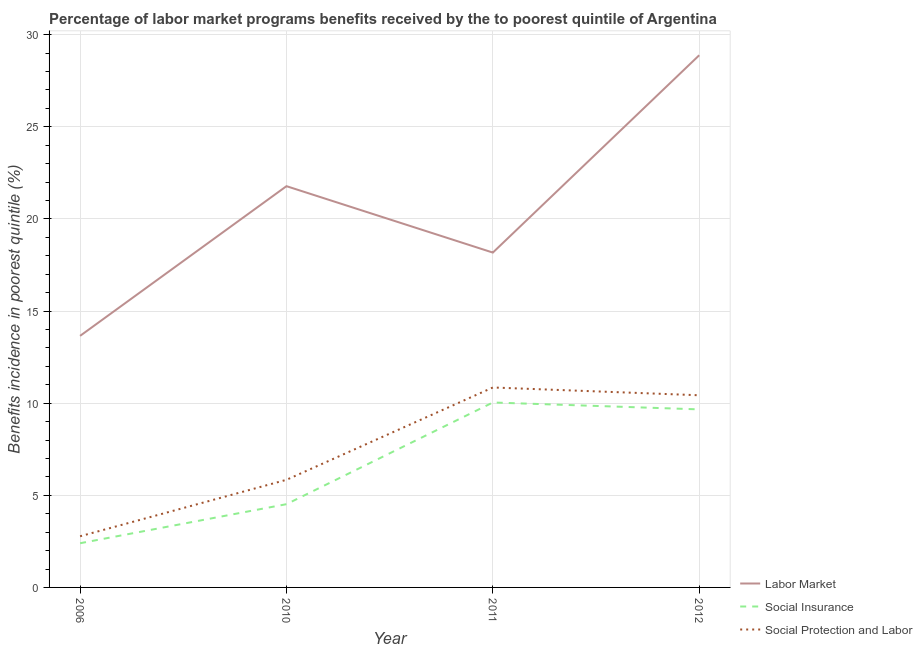Does the line corresponding to percentage of benefits received due to social protection programs intersect with the line corresponding to percentage of benefits received due to labor market programs?
Ensure brevity in your answer.  No. Is the number of lines equal to the number of legend labels?
Offer a terse response. Yes. What is the percentage of benefits received due to labor market programs in 2010?
Your response must be concise. 21.78. Across all years, what is the maximum percentage of benefits received due to social insurance programs?
Keep it short and to the point. 10.04. Across all years, what is the minimum percentage of benefits received due to social insurance programs?
Offer a terse response. 2.4. What is the total percentage of benefits received due to labor market programs in the graph?
Your answer should be very brief. 82.48. What is the difference between the percentage of benefits received due to social insurance programs in 2010 and that in 2012?
Offer a terse response. -5.14. What is the difference between the percentage of benefits received due to social protection programs in 2010 and the percentage of benefits received due to social insurance programs in 2011?
Give a very brief answer. -4.2. What is the average percentage of benefits received due to social insurance programs per year?
Give a very brief answer. 6.65. In the year 2011, what is the difference between the percentage of benefits received due to social protection programs and percentage of benefits received due to labor market programs?
Make the answer very short. -7.32. What is the ratio of the percentage of benefits received due to labor market programs in 2010 to that in 2011?
Give a very brief answer. 1.2. Is the percentage of benefits received due to social insurance programs in 2011 less than that in 2012?
Your answer should be very brief. No. Is the difference between the percentage of benefits received due to social protection programs in 2006 and 2012 greater than the difference between the percentage of benefits received due to labor market programs in 2006 and 2012?
Give a very brief answer. Yes. What is the difference between the highest and the second highest percentage of benefits received due to social protection programs?
Provide a short and direct response. 0.42. What is the difference between the highest and the lowest percentage of benefits received due to labor market programs?
Give a very brief answer. 15.23. In how many years, is the percentage of benefits received due to social protection programs greater than the average percentage of benefits received due to social protection programs taken over all years?
Keep it short and to the point. 2. Is the percentage of benefits received due to labor market programs strictly greater than the percentage of benefits received due to social protection programs over the years?
Your answer should be very brief. Yes. How many lines are there?
Offer a terse response. 3. What is the difference between two consecutive major ticks on the Y-axis?
Your answer should be compact. 5. Does the graph contain grids?
Provide a short and direct response. Yes. How are the legend labels stacked?
Ensure brevity in your answer.  Vertical. What is the title of the graph?
Provide a succinct answer. Percentage of labor market programs benefits received by the to poorest quintile of Argentina. Does "Domestic economy" appear as one of the legend labels in the graph?
Give a very brief answer. No. What is the label or title of the X-axis?
Your answer should be very brief. Year. What is the label or title of the Y-axis?
Give a very brief answer. Benefits incidence in poorest quintile (%). What is the Benefits incidence in poorest quintile (%) of Labor Market in 2006?
Your answer should be very brief. 13.65. What is the Benefits incidence in poorest quintile (%) in Social Insurance in 2006?
Your answer should be compact. 2.4. What is the Benefits incidence in poorest quintile (%) of Social Protection and Labor in 2006?
Your answer should be very brief. 2.78. What is the Benefits incidence in poorest quintile (%) in Labor Market in 2010?
Provide a succinct answer. 21.78. What is the Benefits incidence in poorest quintile (%) of Social Insurance in 2010?
Provide a succinct answer. 4.52. What is the Benefits incidence in poorest quintile (%) of Social Protection and Labor in 2010?
Make the answer very short. 5.84. What is the Benefits incidence in poorest quintile (%) in Labor Market in 2011?
Offer a terse response. 18.17. What is the Benefits incidence in poorest quintile (%) in Social Insurance in 2011?
Provide a short and direct response. 10.04. What is the Benefits incidence in poorest quintile (%) in Social Protection and Labor in 2011?
Give a very brief answer. 10.85. What is the Benefits incidence in poorest quintile (%) of Labor Market in 2012?
Your answer should be very brief. 28.88. What is the Benefits incidence in poorest quintile (%) of Social Insurance in 2012?
Keep it short and to the point. 9.66. What is the Benefits incidence in poorest quintile (%) in Social Protection and Labor in 2012?
Offer a very short reply. 10.43. Across all years, what is the maximum Benefits incidence in poorest quintile (%) in Labor Market?
Your answer should be very brief. 28.88. Across all years, what is the maximum Benefits incidence in poorest quintile (%) of Social Insurance?
Make the answer very short. 10.04. Across all years, what is the maximum Benefits incidence in poorest quintile (%) in Social Protection and Labor?
Your answer should be compact. 10.85. Across all years, what is the minimum Benefits incidence in poorest quintile (%) of Labor Market?
Your answer should be compact. 13.65. Across all years, what is the minimum Benefits incidence in poorest quintile (%) in Social Insurance?
Ensure brevity in your answer.  2.4. Across all years, what is the minimum Benefits incidence in poorest quintile (%) in Social Protection and Labor?
Offer a very short reply. 2.78. What is the total Benefits incidence in poorest quintile (%) of Labor Market in the graph?
Provide a succinct answer. 82.48. What is the total Benefits incidence in poorest quintile (%) of Social Insurance in the graph?
Your answer should be very brief. 26.62. What is the total Benefits incidence in poorest quintile (%) in Social Protection and Labor in the graph?
Your answer should be very brief. 29.9. What is the difference between the Benefits incidence in poorest quintile (%) of Labor Market in 2006 and that in 2010?
Offer a terse response. -8.12. What is the difference between the Benefits incidence in poorest quintile (%) in Social Insurance in 2006 and that in 2010?
Your response must be concise. -2.12. What is the difference between the Benefits incidence in poorest quintile (%) of Social Protection and Labor in 2006 and that in 2010?
Provide a short and direct response. -3.06. What is the difference between the Benefits incidence in poorest quintile (%) of Labor Market in 2006 and that in 2011?
Ensure brevity in your answer.  -4.52. What is the difference between the Benefits incidence in poorest quintile (%) in Social Insurance in 2006 and that in 2011?
Make the answer very short. -7.64. What is the difference between the Benefits incidence in poorest quintile (%) of Social Protection and Labor in 2006 and that in 2011?
Give a very brief answer. -8.07. What is the difference between the Benefits incidence in poorest quintile (%) of Labor Market in 2006 and that in 2012?
Ensure brevity in your answer.  -15.23. What is the difference between the Benefits incidence in poorest quintile (%) in Social Insurance in 2006 and that in 2012?
Ensure brevity in your answer.  -7.26. What is the difference between the Benefits incidence in poorest quintile (%) of Social Protection and Labor in 2006 and that in 2012?
Your answer should be very brief. -7.65. What is the difference between the Benefits incidence in poorest quintile (%) in Labor Market in 2010 and that in 2011?
Your response must be concise. 3.6. What is the difference between the Benefits incidence in poorest quintile (%) of Social Insurance in 2010 and that in 2011?
Provide a succinct answer. -5.52. What is the difference between the Benefits incidence in poorest quintile (%) in Social Protection and Labor in 2010 and that in 2011?
Your response must be concise. -5.01. What is the difference between the Benefits incidence in poorest quintile (%) of Labor Market in 2010 and that in 2012?
Make the answer very short. -7.11. What is the difference between the Benefits incidence in poorest quintile (%) of Social Insurance in 2010 and that in 2012?
Your answer should be very brief. -5.14. What is the difference between the Benefits incidence in poorest quintile (%) of Social Protection and Labor in 2010 and that in 2012?
Offer a very short reply. -4.59. What is the difference between the Benefits incidence in poorest quintile (%) in Labor Market in 2011 and that in 2012?
Provide a succinct answer. -10.71. What is the difference between the Benefits incidence in poorest quintile (%) of Social Insurance in 2011 and that in 2012?
Provide a succinct answer. 0.37. What is the difference between the Benefits incidence in poorest quintile (%) of Social Protection and Labor in 2011 and that in 2012?
Keep it short and to the point. 0.42. What is the difference between the Benefits incidence in poorest quintile (%) in Labor Market in 2006 and the Benefits incidence in poorest quintile (%) in Social Insurance in 2010?
Your answer should be very brief. 9.13. What is the difference between the Benefits incidence in poorest quintile (%) of Labor Market in 2006 and the Benefits incidence in poorest quintile (%) of Social Protection and Labor in 2010?
Keep it short and to the point. 7.81. What is the difference between the Benefits incidence in poorest quintile (%) of Social Insurance in 2006 and the Benefits incidence in poorest quintile (%) of Social Protection and Labor in 2010?
Your response must be concise. -3.44. What is the difference between the Benefits incidence in poorest quintile (%) in Labor Market in 2006 and the Benefits incidence in poorest quintile (%) in Social Insurance in 2011?
Your answer should be very brief. 3.62. What is the difference between the Benefits incidence in poorest quintile (%) of Labor Market in 2006 and the Benefits incidence in poorest quintile (%) of Social Protection and Labor in 2011?
Provide a succinct answer. 2.8. What is the difference between the Benefits incidence in poorest quintile (%) of Social Insurance in 2006 and the Benefits incidence in poorest quintile (%) of Social Protection and Labor in 2011?
Give a very brief answer. -8.45. What is the difference between the Benefits incidence in poorest quintile (%) in Labor Market in 2006 and the Benefits incidence in poorest quintile (%) in Social Insurance in 2012?
Offer a very short reply. 3.99. What is the difference between the Benefits incidence in poorest quintile (%) in Labor Market in 2006 and the Benefits incidence in poorest quintile (%) in Social Protection and Labor in 2012?
Offer a terse response. 3.22. What is the difference between the Benefits incidence in poorest quintile (%) of Social Insurance in 2006 and the Benefits incidence in poorest quintile (%) of Social Protection and Labor in 2012?
Make the answer very short. -8.03. What is the difference between the Benefits incidence in poorest quintile (%) in Labor Market in 2010 and the Benefits incidence in poorest quintile (%) in Social Insurance in 2011?
Offer a terse response. 11.74. What is the difference between the Benefits incidence in poorest quintile (%) in Labor Market in 2010 and the Benefits incidence in poorest quintile (%) in Social Protection and Labor in 2011?
Make the answer very short. 10.93. What is the difference between the Benefits incidence in poorest quintile (%) of Social Insurance in 2010 and the Benefits incidence in poorest quintile (%) of Social Protection and Labor in 2011?
Provide a succinct answer. -6.33. What is the difference between the Benefits incidence in poorest quintile (%) of Labor Market in 2010 and the Benefits incidence in poorest quintile (%) of Social Insurance in 2012?
Provide a succinct answer. 12.11. What is the difference between the Benefits incidence in poorest quintile (%) in Labor Market in 2010 and the Benefits incidence in poorest quintile (%) in Social Protection and Labor in 2012?
Offer a terse response. 11.35. What is the difference between the Benefits incidence in poorest quintile (%) of Social Insurance in 2010 and the Benefits incidence in poorest quintile (%) of Social Protection and Labor in 2012?
Offer a very short reply. -5.91. What is the difference between the Benefits incidence in poorest quintile (%) of Labor Market in 2011 and the Benefits incidence in poorest quintile (%) of Social Insurance in 2012?
Keep it short and to the point. 8.51. What is the difference between the Benefits incidence in poorest quintile (%) of Labor Market in 2011 and the Benefits incidence in poorest quintile (%) of Social Protection and Labor in 2012?
Provide a succinct answer. 7.74. What is the difference between the Benefits incidence in poorest quintile (%) of Social Insurance in 2011 and the Benefits incidence in poorest quintile (%) of Social Protection and Labor in 2012?
Make the answer very short. -0.39. What is the average Benefits incidence in poorest quintile (%) in Labor Market per year?
Make the answer very short. 20.62. What is the average Benefits incidence in poorest quintile (%) of Social Insurance per year?
Ensure brevity in your answer.  6.65. What is the average Benefits incidence in poorest quintile (%) of Social Protection and Labor per year?
Your answer should be compact. 7.47. In the year 2006, what is the difference between the Benefits incidence in poorest quintile (%) of Labor Market and Benefits incidence in poorest quintile (%) of Social Insurance?
Give a very brief answer. 11.25. In the year 2006, what is the difference between the Benefits incidence in poorest quintile (%) in Labor Market and Benefits incidence in poorest quintile (%) in Social Protection and Labor?
Offer a terse response. 10.88. In the year 2006, what is the difference between the Benefits incidence in poorest quintile (%) in Social Insurance and Benefits incidence in poorest quintile (%) in Social Protection and Labor?
Give a very brief answer. -0.38. In the year 2010, what is the difference between the Benefits incidence in poorest quintile (%) of Labor Market and Benefits incidence in poorest quintile (%) of Social Insurance?
Provide a succinct answer. 17.26. In the year 2010, what is the difference between the Benefits incidence in poorest quintile (%) in Labor Market and Benefits incidence in poorest quintile (%) in Social Protection and Labor?
Make the answer very short. 15.94. In the year 2010, what is the difference between the Benefits incidence in poorest quintile (%) of Social Insurance and Benefits incidence in poorest quintile (%) of Social Protection and Labor?
Offer a very short reply. -1.32. In the year 2011, what is the difference between the Benefits incidence in poorest quintile (%) of Labor Market and Benefits incidence in poorest quintile (%) of Social Insurance?
Keep it short and to the point. 8.14. In the year 2011, what is the difference between the Benefits incidence in poorest quintile (%) of Labor Market and Benefits incidence in poorest quintile (%) of Social Protection and Labor?
Provide a succinct answer. 7.32. In the year 2011, what is the difference between the Benefits incidence in poorest quintile (%) of Social Insurance and Benefits incidence in poorest quintile (%) of Social Protection and Labor?
Provide a short and direct response. -0.81. In the year 2012, what is the difference between the Benefits incidence in poorest quintile (%) of Labor Market and Benefits incidence in poorest quintile (%) of Social Insurance?
Make the answer very short. 19.22. In the year 2012, what is the difference between the Benefits incidence in poorest quintile (%) in Labor Market and Benefits incidence in poorest quintile (%) in Social Protection and Labor?
Give a very brief answer. 18.45. In the year 2012, what is the difference between the Benefits incidence in poorest quintile (%) of Social Insurance and Benefits incidence in poorest quintile (%) of Social Protection and Labor?
Provide a succinct answer. -0.77. What is the ratio of the Benefits incidence in poorest quintile (%) in Labor Market in 2006 to that in 2010?
Offer a very short reply. 0.63. What is the ratio of the Benefits incidence in poorest quintile (%) in Social Insurance in 2006 to that in 2010?
Make the answer very short. 0.53. What is the ratio of the Benefits incidence in poorest quintile (%) in Social Protection and Labor in 2006 to that in 2010?
Make the answer very short. 0.48. What is the ratio of the Benefits incidence in poorest quintile (%) of Labor Market in 2006 to that in 2011?
Make the answer very short. 0.75. What is the ratio of the Benefits incidence in poorest quintile (%) of Social Insurance in 2006 to that in 2011?
Provide a succinct answer. 0.24. What is the ratio of the Benefits incidence in poorest quintile (%) of Social Protection and Labor in 2006 to that in 2011?
Keep it short and to the point. 0.26. What is the ratio of the Benefits incidence in poorest quintile (%) in Labor Market in 2006 to that in 2012?
Your response must be concise. 0.47. What is the ratio of the Benefits incidence in poorest quintile (%) of Social Insurance in 2006 to that in 2012?
Offer a very short reply. 0.25. What is the ratio of the Benefits incidence in poorest quintile (%) in Social Protection and Labor in 2006 to that in 2012?
Give a very brief answer. 0.27. What is the ratio of the Benefits incidence in poorest quintile (%) in Labor Market in 2010 to that in 2011?
Provide a short and direct response. 1.2. What is the ratio of the Benefits incidence in poorest quintile (%) in Social Insurance in 2010 to that in 2011?
Ensure brevity in your answer.  0.45. What is the ratio of the Benefits incidence in poorest quintile (%) of Social Protection and Labor in 2010 to that in 2011?
Your answer should be compact. 0.54. What is the ratio of the Benefits incidence in poorest quintile (%) of Labor Market in 2010 to that in 2012?
Give a very brief answer. 0.75. What is the ratio of the Benefits incidence in poorest quintile (%) of Social Insurance in 2010 to that in 2012?
Give a very brief answer. 0.47. What is the ratio of the Benefits incidence in poorest quintile (%) in Social Protection and Labor in 2010 to that in 2012?
Offer a terse response. 0.56. What is the ratio of the Benefits incidence in poorest quintile (%) of Labor Market in 2011 to that in 2012?
Your answer should be very brief. 0.63. What is the ratio of the Benefits incidence in poorest quintile (%) in Social Insurance in 2011 to that in 2012?
Keep it short and to the point. 1.04. What is the ratio of the Benefits incidence in poorest quintile (%) in Social Protection and Labor in 2011 to that in 2012?
Your answer should be very brief. 1.04. What is the difference between the highest and the second highest Benefits incidence in poorest quintile (%) in Labor Market?
Give a very brief answer. 7.11. What is the difference between the highest and the second highest Benefits incidence in poorest quintile (%) in Social Insurance?
Keep it short and to the point. 0.37. What is the difference between the highest and the second highest Benefits incidence in poorest quintile (%) in Social Protection and Labor?
Make the answer very short. 0.42. What is the difference between the highest and the lowest Benefits incidence in poorest quintile (%) of Labor Market?
Keep it short and to the point. 15.23. What is the difference between the highest and the lowest Benefits incidence in poorest quintile (%) in Social Insurance?
Offer a very short reply. 7.64. What is the difference between the highest and the lowest Benefits incidence in poorest quintile (%) of Social Protection and Labor?
Keep it short and to the point. 8.07. 